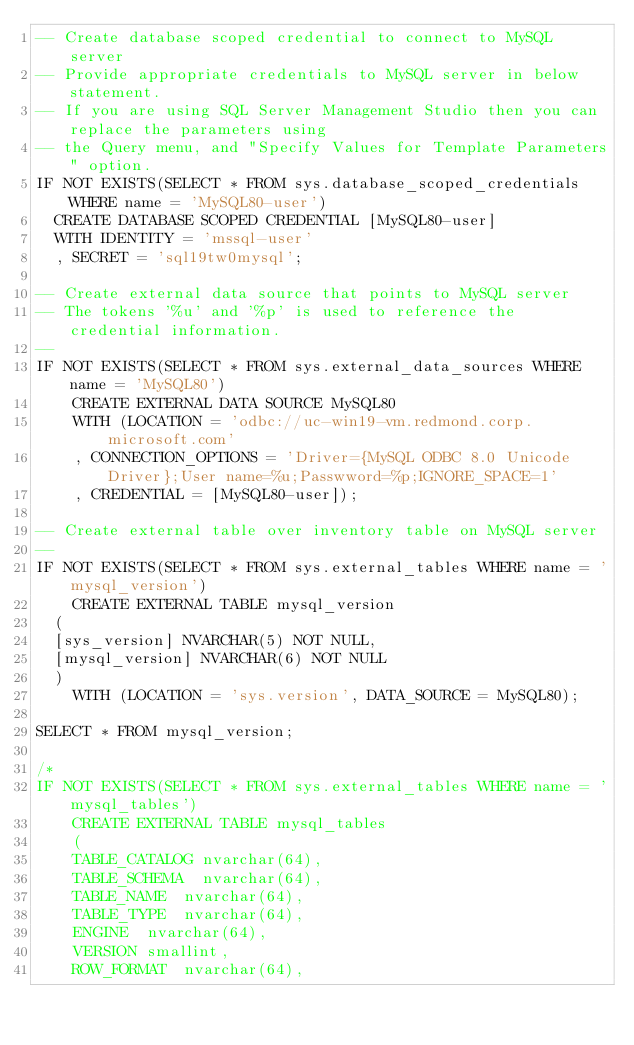Convert code to text. <code><loc_0><loc_0><loc_500><loc_500><_SQL_>-- Create database scoped credential to connect to MySQL server
-- Provide appropriate credentials to MySQL server in below statement.
-- If you are using SQL Server Management Studio then you can replace the parameters using
-- the Query menu, and "Specify Values for Template Parameters" option.
IF NOT EXISTS(SELECT * FROM sys.database_scoped_credentials WHERE name = 'MySQL80-user')
  CREATE DATABASE SCOPED CREDENTIAL [MySQL80-user]
  WITH IDENTITY = 'mssql-user'
  , SECRET = 'sql19tw0mysql';

-- Create external data source that points to MySQL server
-- The tokens '%u' and '%p' is used to reference the credential information.
--
IF NOT EXISTS(SELECT * FROM sys.external_data_sources WHERE name = 'MySQL80')
    CREATE EXTERNAL DATA SOURCE MySQL80
    WITH (LOCATION = 'odbc://uc-win19-vm.redmond.corp.microsoft.com'
    , CONNECTION_OPTIONS = 'Driver={MySQL ODBC 8.0 Unicode Driver};User name=%u;Passwword=%p;IGNORE_SPACE=1'
    , CREDENTIAL = [MySQL80-user]);

-- Create external table over inventory table on MySQL server
--
IF NOT EXISTS(SELECT * FROM sys.external_tables WHERE name = 'mysql_version')
    CREATE EXTERNAL TABLE mysql_version
	(
	[sys_version] NVARCHAR(5) NOT NULL,
	[mysql_version] NVARCHAR(6) NOT NULL
	)
    WITH (LOCATION = 'sys.version', DATA_SOURCE = MySQL80);

SELECT * FROM mysql_version;

/*
IF NOT EXISTS(SELECT * FROM sys.external_tables WHERE name = 'mysql_tables')
    CREATE EXTERNAL TABLE mysql_tables
    (
		TABLE_CATALOG	nvarchar(64),	
		TABLE_SCHEMA	nvarchar(64),		
		TABLE_NAME	nvarchar(64),	
		TABLE_TYPE	nvarchar(64),		
		ENGINE	nvarchar(64),		
		VERSION	smallint,			
		ROW_FORMAT	nvarchar(64),		</code> 